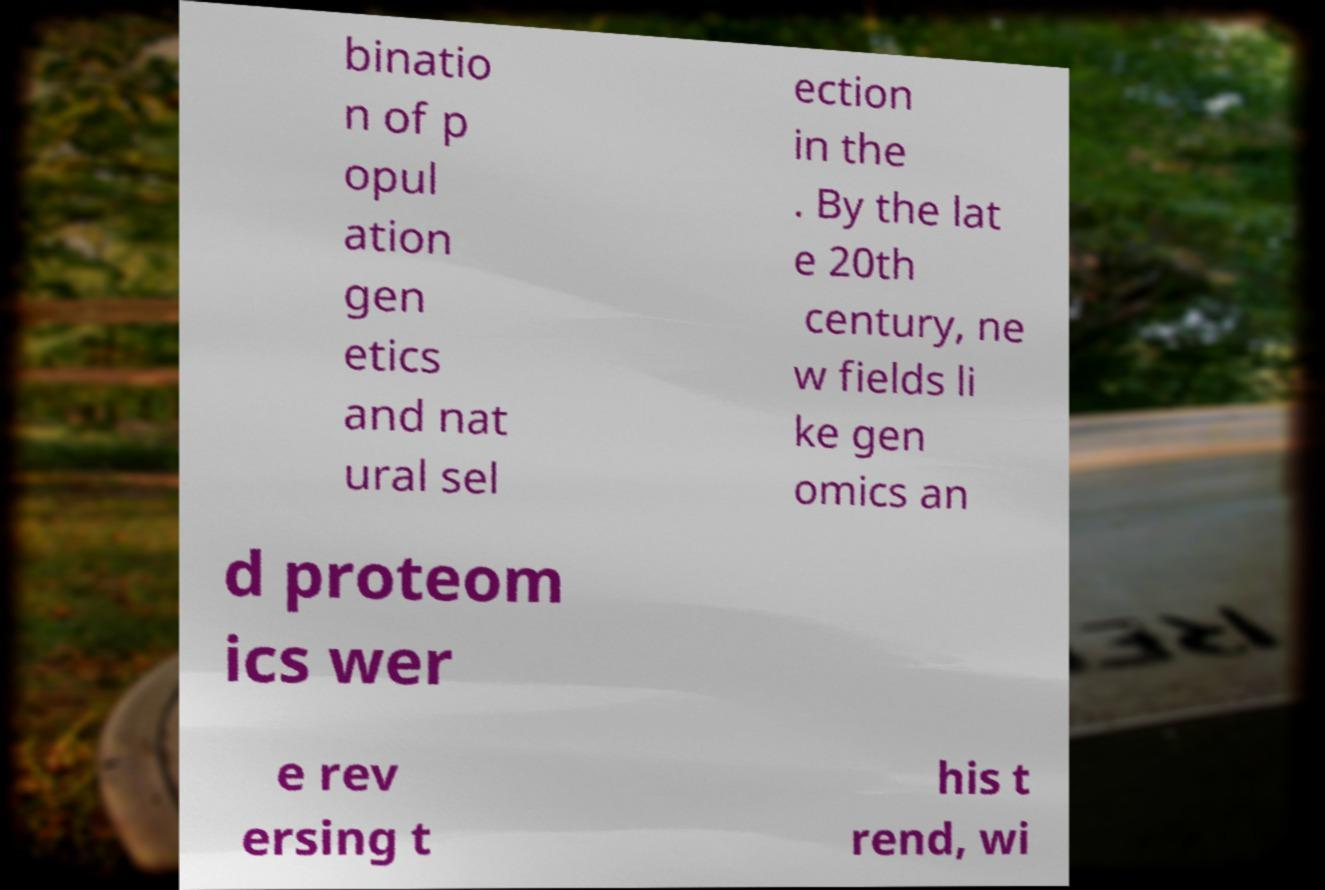Can you read and provide the text displayed in the image?This photo seems to have some interesting text. Can you extract and type it out for me? binatio n of p opul ation gen etics and nat ural sel ection in the . By the lat e 20th century, ne w fields li ke gen omics an d proteom ics wer e rev ersing t his t rend, wi 